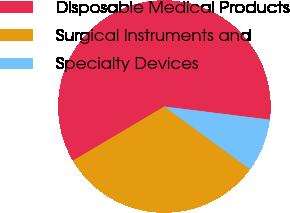Convert chart. <chart><loc_0><loc_0><loc_500><loc_500><pie_chart><fcel>Disposable Medical Products<fcel>Surgical Instruments and<fcel>Specialty Devices<nl><fcel>60.49%<fcel>31.43%<fcel>8.08%<nl></chart> 